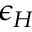Convert formula to latex. <formula><loc_0><loc_0><loc_500><loc_500>\epsilon _ { H }</formula> 